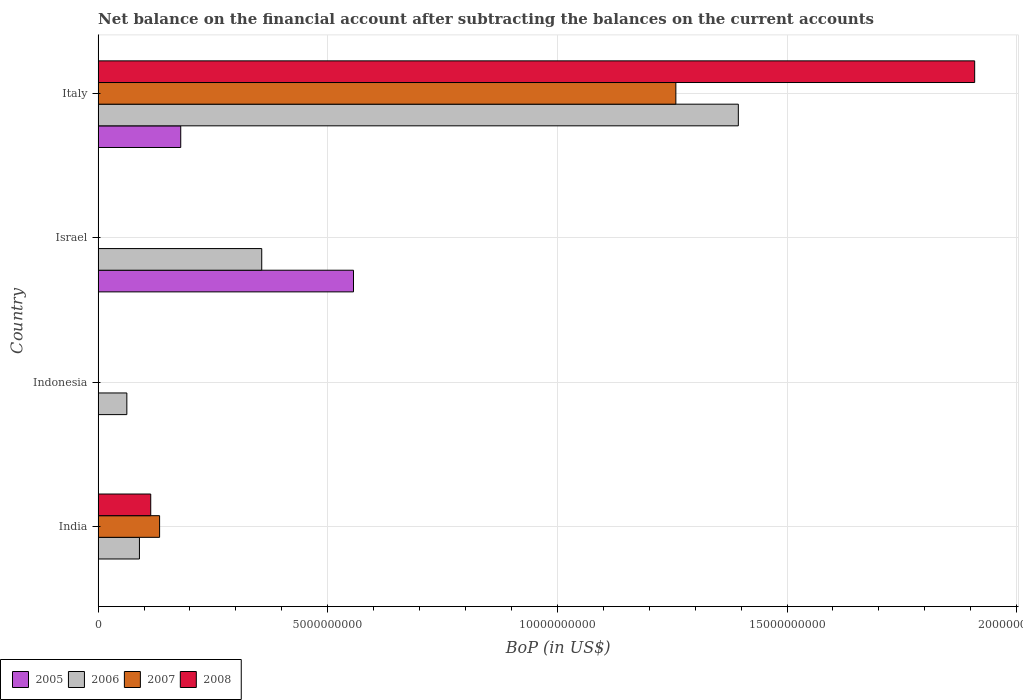How many different coloured bars are there?
Make the answer very short. 4. Are the number of bars per tick equal to the number of legend labels?
Keep it short and to the point. No. How many bars are there on the 4th tick from the top?
Your answer should be compact. 3. How many bars are there on the 2nd tick from the bottom?
Give a very brief answer. 1. In how many cases, is the number of bars for a given country not equal to the number of legend labels?
Offer a terse response. 3. Across all countries, what is the maximum Balance of Payments in 2007?
Offer a very short reply. 1.26e+1. Across all countries, what is the minimum Balance of Payments in 2007?
Provide a short and direct response. 0. What is the total Balance of Payments in 2005 in the graph?
Offer a terse response. 7.36e+09. What is the difference between the Balance of Payments in 2007 in India and the Balance of Payments in 2005 in Israel?
Your response must be concise. -4.22e+09. What is the average Balance of Payments in 2005 per country?
Provide a succinct answer. 1.84e+09. What is the difference between the Balance of Payments in 2006 and Balance of Payments in 2007 in India?
Provide a succinct answer. -4.39e+08. What is the ratio of the Balance of Payments in 2006 in Indonesia to that in Italy?
Provide a short and direct response. 0.04. What is the difference between the highest and the second highest Balance of Payments in 2006?
Your answer should be very brief. 1.04e+1. What is the difference between the highest and the lowest Balance of Payments in 2007?
Your response must be concise. 1.26e+1. Is the sum of the Balance of Payments in 2006 in Indonesia and Italy greater than the maximum Balance of Payments in 2007 across all countries?
Your response must be concise. Yes. Are all the bars in the graph horizontal?
Offer a terse response. Yes. How many countries are there in the graph?
Give a very brief answer. 4. What is the difference between two consecutive major ticks on the X-axis?
Your answer should be compact. 5.00e+09. Does the graph contain any zero values?
Keep it short and to the point. Yes. Does the graph contain grids?
Ensure brevity in your answer.  Yes. Where does the legend appear in the graph?
Your response must be concise. Bottom left. How are the legend labels stacked?
Your response must be concise. Horizontal. What is the title of the graph?
Offer a very short reply. Net balance on the financial account after subtracting the balances on the current accounts. What is the label or title of the X-axis?
Offer a very short reply. BoP (in US$). What is the BoP (in US$) of 2006 in India?
Keep it short and to the point. 9.00e+08. What is the BoP (in US$) of 2007 in India?
Give a very brief answer. 1.34e+09. What is the BoP (in US$) of 2008 in India?
Make the answer very short. 1.15e+09. What is the BoP (in US$) of 2005 in Indonesia?
Your response must be concise. 0. What is the BoP (in US$) in 2006 in Indonesia?
Offer a terse response. 6.25e+08. What is the BoP (in US$) of 2007 in Indonesia?
Offer a very short reply. 0. What is the BoP (in US$) in 2005 in Israel?
Offer a very short reply. 5.56e+09. What is the BoP (in US$) of 2006 in Israel?
Your answer should be compact. 3.56e+09. What is the BoP (in US$) in 2008 in Israel?
Your answer should be very brief. 0. What is the BoP (in US$) of 2005 in Italy?
Ensure brevity in your answer.  1.80e+09. What is the BoP (in US$) in 2006 in Italy?
Keep it short and to the point. 1.39e+1. What is the BoP (in US$) of 2007 in Italy?
Your response must be concise. 1.26e+1. What is the BoP (in US$) of 2008 in Italy?
Offer a terse response. 1.91e+1. Across all countries, what is the maximum BoP (in US$) in 2005?
Ensure brevity in your answer.  5.56e+09. Across all countries, what is the maximum BoP (in US$) of 2006?
Offer a very short reply. 1.39e+1. Across all countries, what is the maximum BoP (in US$) of 2007?
Your response must be concise. 1.26e+1. Across all countries, what is the maximum BoP (in US$) in 2008?
Ensure brevity in your answer.  1.91e+1. Across all countries, what is the minimum BoP (in US$) of 2005?
Ensure brevity in your answer.  0. Across all countries, what is the minimum BoP (in US$) in 2006?
Provide a succinct answer. 6.25e+08. Across all countries, what is the minimum BoP (in US$) in 2007?
Ensure brevity in your answer.  0. Across all countries, what is the minimum BoP (in US$) of 2008?
Your response must be concise. 0. What is the total BoP (in US$) of 2005 in the graph?
Your response must be concise. 7.36e+09. What is the total BoP (in US$) in 2006 in the graph?
Give a very brief answer. 1.90e+1. What is the total BoP (in US$) in 2007 in the graph?
Your answer should be very brief. 1.39e+1. What is the total BoP (in US$) in 2008 in the graph?
Offer a terse response. 2.02e+1. What is the difference between the BoP (in US$) in 2006 in India and that in Indonesia?
Your answer should be very brief. 2.74e+08. What is the difference between the BoP (in US$) of 2006 in India and that in Israel?
Keep it short and to the point. -2.66e+09. What is the difference between the BoP (in US$) of 2006 in India and that in Italy?
Offer a very short reply. -1.30e+1. What is the difference between the BoP (in US$) in 2007 in India and that in Italy?
Give a very brief answer. -1.12e+1. What is the difference between the BoP (in US$) in 2008 in India and that in Italy?
Ensure brevity in your answer.  -1.79e+1. What is the difference between the BoP (in US$) in 2006 in Indonesia and that in Israel?
Make the answer very short. -2.94e+09. What is the difference between the BoP (in US$) of 2006 in Indonesia and that in Italy?
Provide a short and direct response. -1.33e+1. What is the difference between the BoP (in US$) in 2005 in Israel and that in Italy?
Offer a very short reply. 3.76e+09. What is the difference between the BoP (in US$) in 2006 in Israel and that in Italy?
Provide a succinct answer. -1.04e+1. What is the difference between the BoP (in US$) of 2006 in India and the BoP (in US$) of 2007 in Italy?
Your response must be concise. -1.17e+1. What is the difference between the BoP (in US$) in 2006 in India and the BoP (in US$) in 2008 in Italy?
Ensure brevity in your answer.  -1.82e+1. What is the difference between the BoP (in US$) in 2007 in India and the BoP (in US$) in 2008 in Italy?
Offer a terse response. -1.77e+1. What is the difference between the BoP (in US$) of 2006 in Indonesia and the BoP (in US$) of 2007 in Italy?
Keep it short and to the point. -1.20e+1. What is the difference between the BoP (in US$) in 2006 in Indonesia and the BoP (in US$) in 2008 in Italy?
Offer a very short reply. -1.85e+1. What is the difference between the BoP (in US$) of 2005 in Israel and the BoP (in US$) of 2006 in Italy?
Keep it short and to the point. -8.38e+09. What is the difference between the BoP (in US$) of 2005 in Israel and the BoP (in US$) of 2007 in Italy?
Provide a succinct answer. -7.02e+09. What is the difference between the BoP (in US$) of 2005 in Israel and the BoP (in US$) of 2008 in Italy?
Your answer should be very brief. -1.35e+1. What is the difference between the BoP (in US$) of 2006 in Israel and the BoP (in US$) of 2007 in Italy?
Provide a succinct answer. -9.02e+09. What is the difference between the BoP (in US$) in 2006 in Israel and the BoP (in US$) in 2008 in Italy?
Keep it short and to the point. -1.55e+1. What is the average BoP (in US$) of 2005 per country?
Make the answer very short. 1.84e+09. What is the average BoP (in US$) in 2006 per country?
Give a very brief answer. 4.76e+09. What is the average BoP (in US$) of 2007 per country?
Provide a succinct answer. 3.48e+09. What is the average BoP (in US$) of 2008 per country?
Give a very brief answer. 5.06e+09. What is the difference between the BoP (in US$) of 2006 and BoP (in US$) of 2007 in India?
Give a very brief answer. -4.39e+08. What is the difference between the BoP (in US$) of 2006 and BoP (in US$) of 2008 in India?
Your answer should be very brief. -2.46e+08. What is the difference between the BoP (in US$) of 2007 and BoP (in US$) of 2008 in India?
Ensure brevity in your answer.  1.93e+08. What is the difference between the BoP (in US$) in 2005 and BoP (in US$) in 2006 in Israel?
Make the answer very short. 2.00e+09. What is the difference between the BoP (in US$) of 2005 and BoP (in US$) of 2006 in Italy?
Give a very brief answer. -1.21e+1. What is the difference between the BoP (in US$) in 2005 and BoP (in US$) in 2007 in Italy?
Provide a succinct answer. -1.08e+1. What is the difference between the BoP (in US$) in 2005 and BoP (in US$) in 2008 in Italy?
Your answer should be very brief. -1.73e+1. What is the difference between the BoP (in US$) in 2006 and BoP (in US$) in 2007 in Italy?
Offer a very short reply. 1.36e+09. What is the difference between the BoP (in US$) in 2006 and BoP (in US$) in 2008 in Italy?
Offer a very short reply. -5.15e+09. What is the difference between the BoP (in US$) in 2007 and BoP (in US$) in 2008 in Italy?
Provide a short and direct response. -6.51e+09. What is the ratio of the BoP (in US$) in 2006 in India to that in Indonesia?
Give a very brief answer. 1.44. What is the ratio of the BoP (in US$) in 2006 in India to that in Israel?
Your answer should be very brief. 0.25. What is the ratio of the BoP (in US$) of 2006 in India to that in Italy?
Provide a short and direct response. 0.06. What is the ratio of the BoP (in US$) of 2007 in India to that in Italy?
Your answer should be compact. 0.11. What is the ratio of the BoP (in US$) in 2008 in India to that in Italy?
Offer a very short reply. 0.06. What is the ratio of the BoP (in US$) in 2006 in Indonesia to that in Israel?
Provide a succinct answer. 0.18. What is the ratio of the BoP (in US$) of 2006 in Indonesia to that in Italy?
Keep it short and to the point. 0.04. What is the ratio of the BoP (in US$) in 2005 in Israel to that in Italy?
Provide a short and direct response. 3.09. What is the ratio of the BoP (in US$) of 2006 in Israel to that in Italy?
Provide a succinct answer. 0.26. What is the difference between the highest and the second highest BoP (in US$) of 2006?
Make the answer very short. 1.04e+1. What is the difference between the highest and the lowest BoP (in US$) in 2005?
Provide a succinct answer. 5.56e+09. What is the difference between the highest and the lowest BoP (in US$) of 2006?
Offer a terse response. 1.33e+1. What is the difference between the highest and the lowest BoP (in US$) in 2007?
Make the answer very short. 1.26e+1. What is the difference between the highest and the lowest BoP (in US$) of 2008?
Provide a short and direct response. 1.91e+1. 